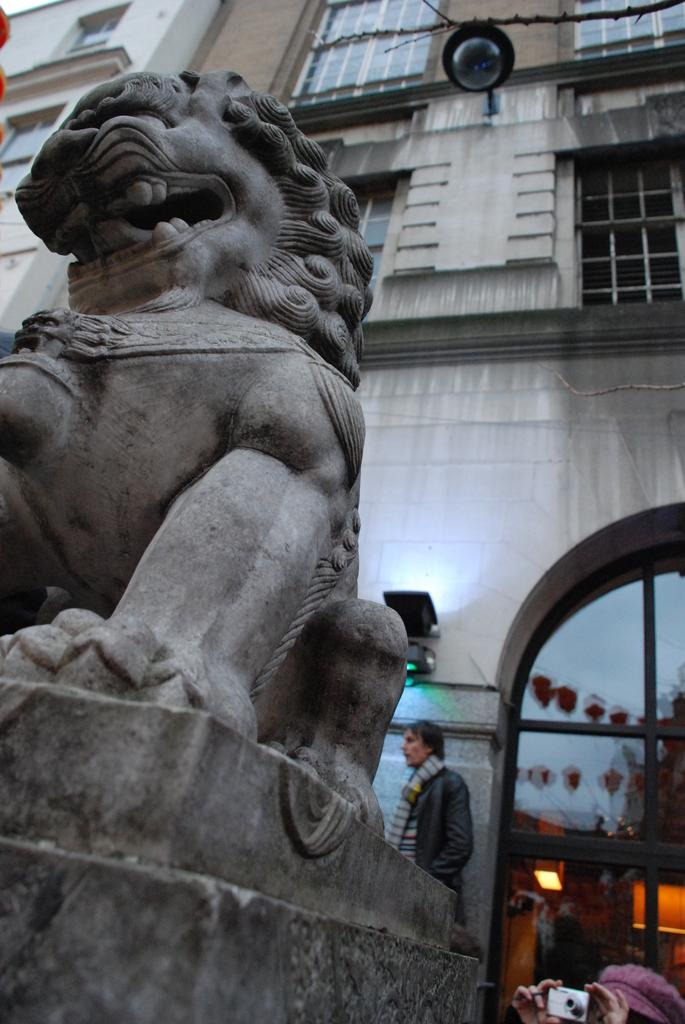What is the main subject in the foreground of the image? There is a lion's statue in the foreground of the image. What can be seen in the background of the image? There are buildings, windows, and a door visible in the background of the image. How many people are in the background of the image? There are four persons in the background of the image. Can you describe the time of day when the image was likely taken? The image was likely taken during the day, as there is no indication of darkness or artificial lighting. What type of lace is draped over the horse in the image? There is no horse or lace present in the image; it features a lion's statue and various elements in the background. 